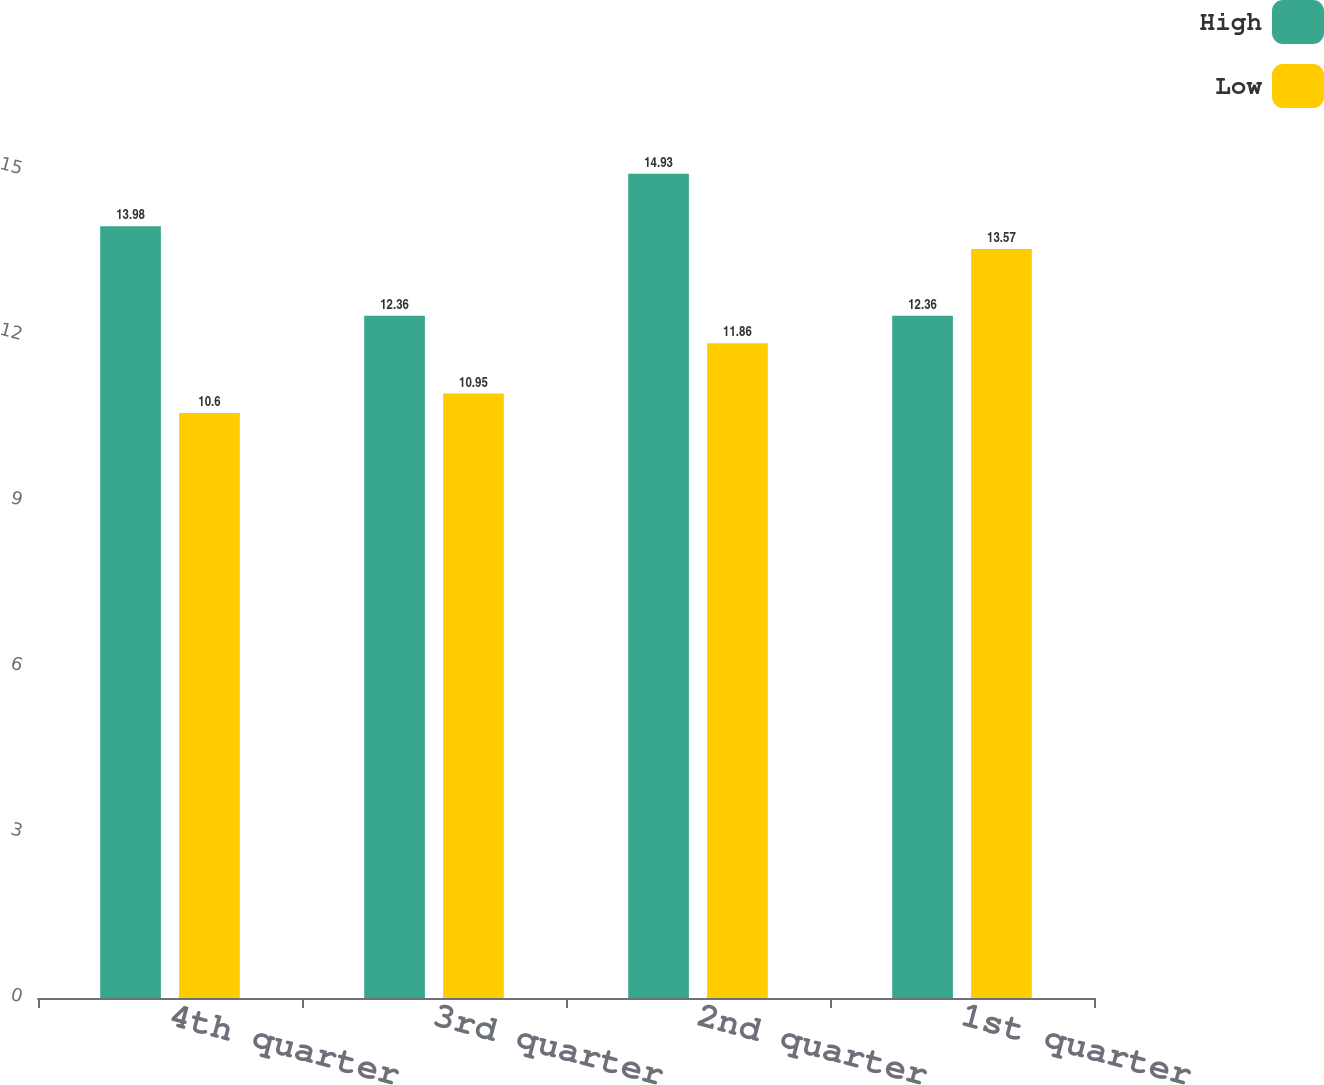Convert chart. <chart><loc_0><loc_0><loc_500><loc_500><stacked_bar_chart><ecel><fcel>4th quarter<fcel>3rd quarter<fcel>2nd quarter<fcel>1st quarter<nl><fcel>High<fcel>13.98<fcel>12.36<fcel>14.93<fcel>12.36<nl><fcel>Low<fcel>10.6<fcel>10.95<fcel>11.86<fcel>13.57<nl></chart> 